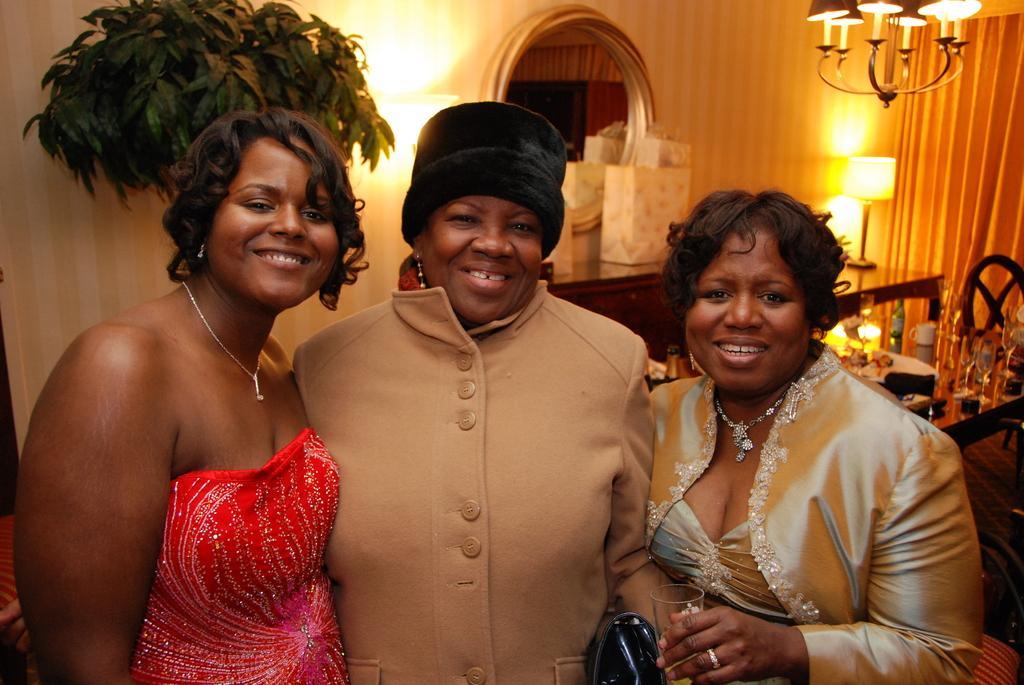In one or two sentences, can you explain what this image depicts? In this picture there are three African woman standing, smiling and giving a pose into the camera. Behind there is cotton curtain and a table with the yellow color table light and a mirror on the wall. Above we can see the hanging chandelier. 